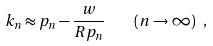<formula> <loc_0><loc_0><loc_500><loc_500>k _ { n } \approx p _ { n } - \frac { w } { R p _ { n } } \quad ( n \to \infty ) \ ,</formula> 